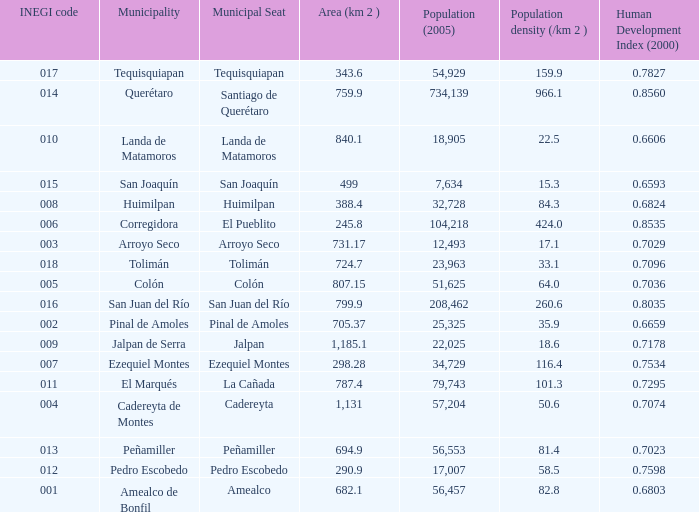WHat is the amount of Human Development Index (2000) that has a Population (2005) of 54,929, and an Area (km 2 ) larger than 343.6? 0.0. 